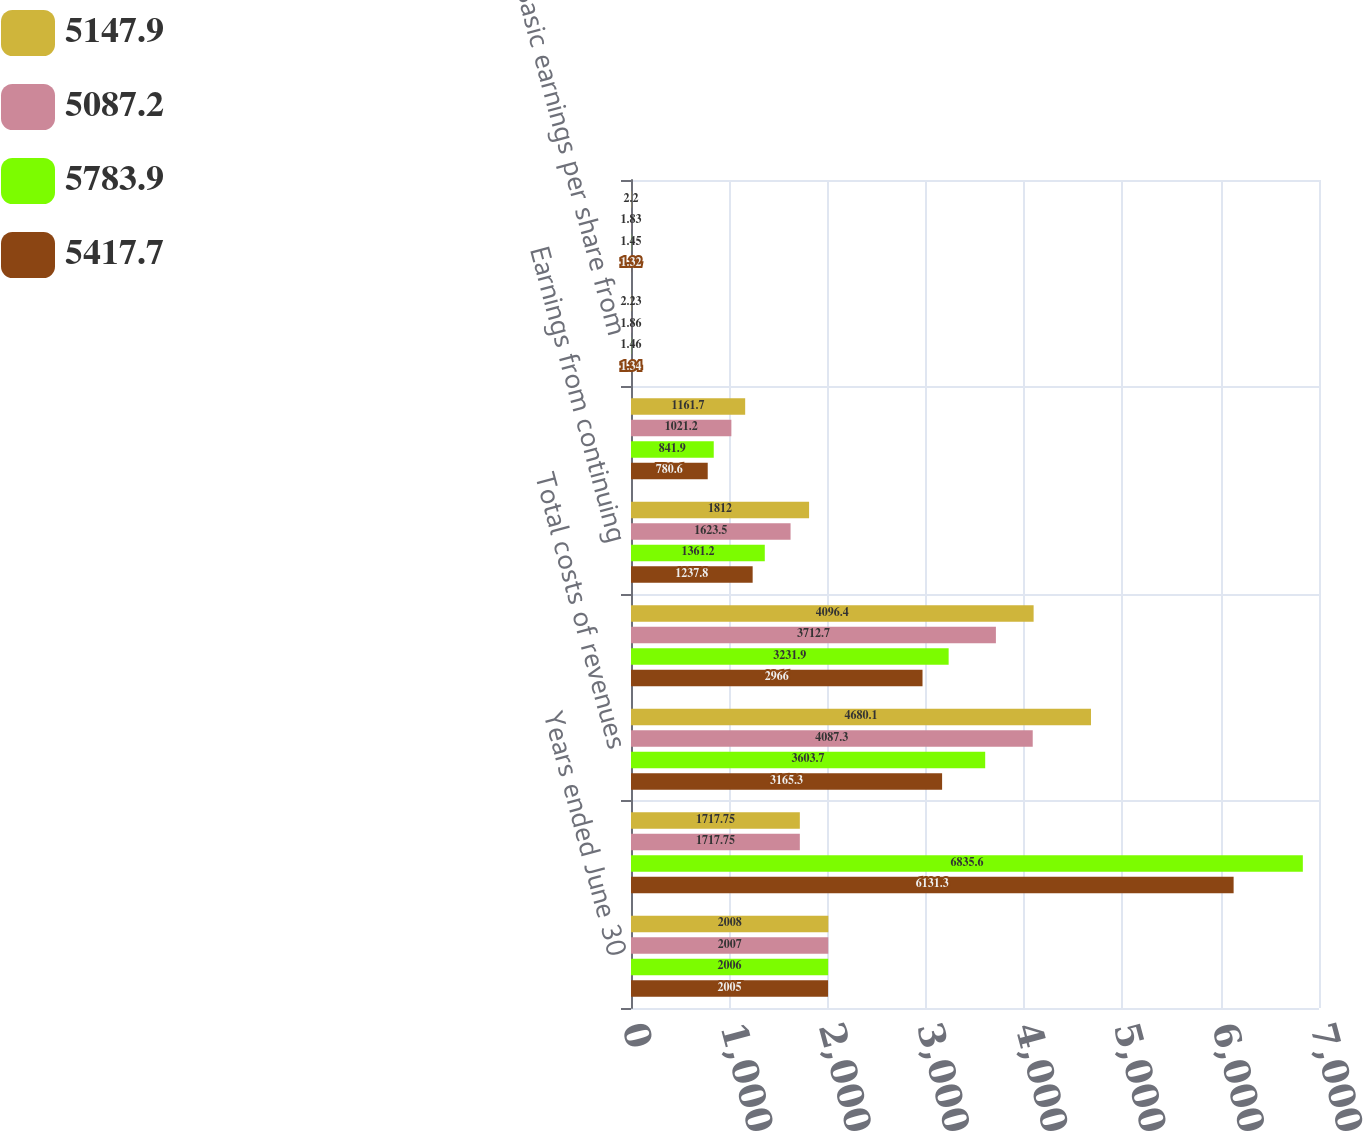<chart> <loc_0><loc_0><loc_500><loc_500><stacked_bar_chart><ecel><fcel>Years ended June 30<fcel>Total revenues<fcel>Total costs of revenues<fcel>Gross profit<fcel>Earnings from continuing<fcel>Net earnings from continuing<fcel>Basic earnings per share from<fcel>Diluted earnings per share<nl><fcel>5147.9<fcel>2008<fcel>1717.75<fcel>4680.1<fcel>4096.4<fcel>1812<fcel>1161.7<fcel>2.23<fcel>2.2<nl><fcel>5087.2<fcel>2007<fcel>1717.75<fcel>4087.3<fcel>3712.7<fcel>1623.5<fcel>1021.2<fcel>1.86<fcel>1.83<nl><fcel>5783.9<fcel>2006<fcel>6835.6<fcel>3603.7<fcel>3231.9<fcel>1361.2<fcel>841.9<fcel>1.46<fcel>1.45<nl><fcel>5417.7<fcel>2005<fcel>6131.3<fcel>3165.3<fcel>2966<fcel>1237.8<fcel>780.6<fcel>1.34<fcel>1.32<nl></chart> 